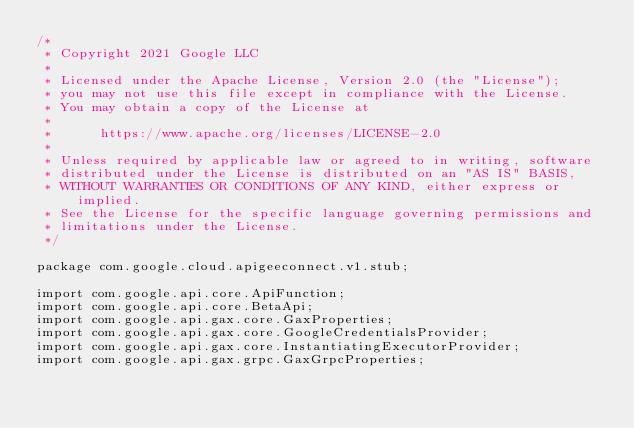<code> <loc_0><loc_0><loc_500><loc_500><_Java_>/*
 * Copyright 2021 Google LLC
 *
 * Licensed under the Apache License, Version 2.0 (the "License");
 * you may not use this file except in compliance with the License.
 * You may obtain a copy of the License at
 *
 *      https://www.apache.org/licenses/LICENSE-2.0
 *
 * Unless required by applicable law or agreed to in writing, software
 * distributed under the License is distributed on an "AS IS" BASIS,
 * WITHOUT WARRANTIES OR CONDITIONS OF ANY KIND, either express or implied.
 * See the License for the specific language governing permissions and
 * limitations under the License.
 */

package com.google.cloud.apigeeconnect.v1.stub;

import com.google.api.core.ApiFunction;
import com.google.api.core.BetaApi;
import com.google.api.gax.core.GaxProperties;
import com.google.api.gax.core.GoogleCredentialsProvider;
import com.google.api.gax.core.InstantiatingExecutorProvider;
import com.google.api.gax.grpc.GaxGrpcProperties;</code> 